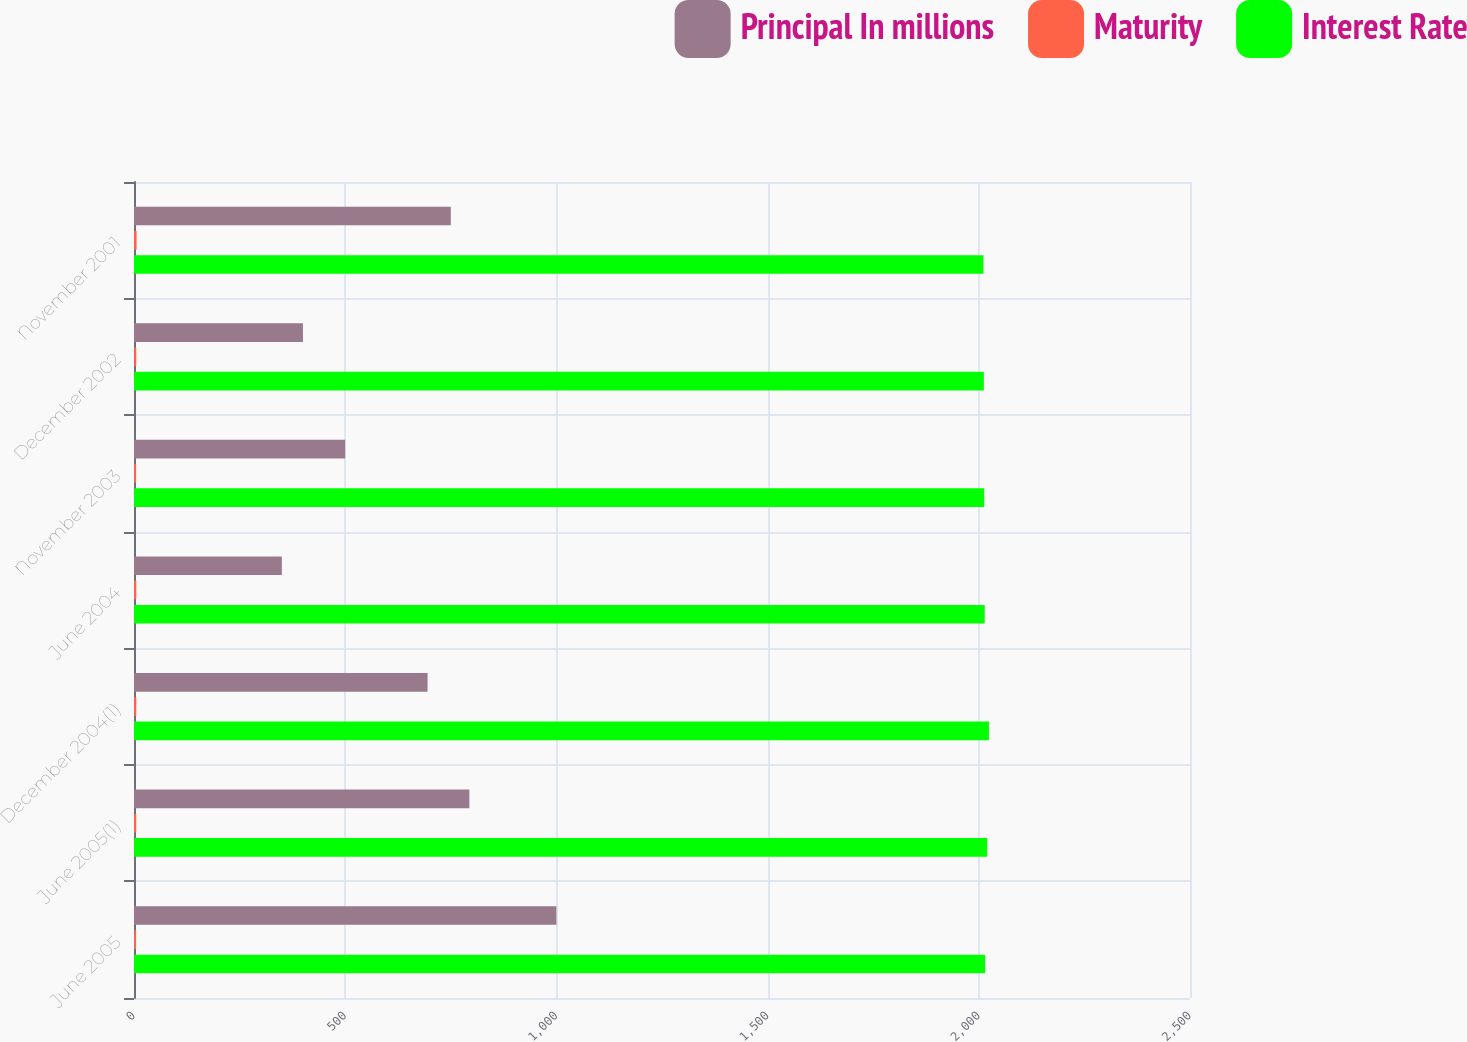Convert chart. <chart><loc_0><loc_0><loc_500><loc_500><stacked_bar_chart><ecel><fcel>June 2005<fcel>June 2005(1)<fcel>December 2004(1)<fcel>June 2004<fcel>November 2003<fcel>December 2002<fcel>November 2001<nl><fcel>Principal In millions<fcel>1000<fcel>794<fcel>695<fcel>350<fcel>500<fcel>400<fcel>750<nl><fcel>Maturity<fcel>5<fcel>5.25<fcel>5.38<fcel>5.5<fcel>5<fcel>5.38<fcel>6.13<nl><fcel>Interest Rate<fcel>2015<fcel>2020<fcel>2024<fcel>2014<fcel>2013<fcel>2012<fcel>2011<nl></chart> 